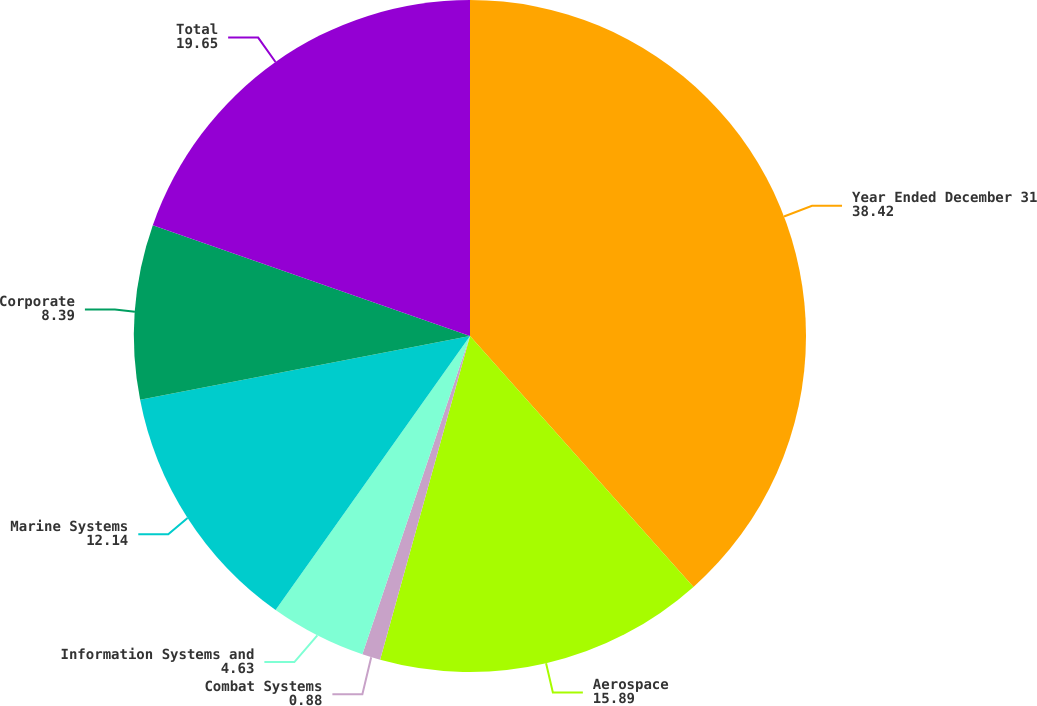<chart> <loc_0><loc_0><loc_500><loc_500><pie_chart><fcel>Year Ended December 31<fcel>Aerospace<fcel>Combat Systems<fcel>Information Systems and<fcel>Marine Systems<fcel>Corporate<fcel>Total<nl><fcel>38.42%<fcel>15.89%<fcel>0.88%<fcel>4.63%<fcel>12.14%<fcel>8.39%<fcel>19.65%<nl></chart> 